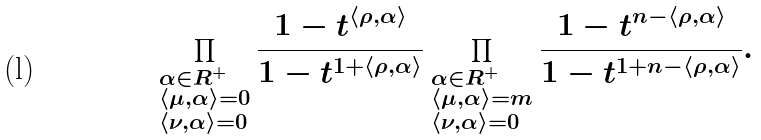Convert formula to latex. <formula><loc_0><loc_0><loc_500><loc_500>\prod _ { \begin{subarray} { c } \alpha \in R ^ { + } \\ \langle \mu , \alpha \rangle = 0 \\ \langle \nu , \alpha \rangle = 0 \end{subarray} } \frac { 1 - t ^ { \langle \rho , \alpha \rangle } } { 1 - t ^ { 1 + \langle \rho , \alpha \rangle } } \prod _ { \begin{subarray} { c } \alpha \in R ^ { + } \\ \langle \mu , \alpha \rangle = m \\ \langle \nu , \alpha \rangle = 0 \end{subarray} } \frac { 1 - t ^ { n - \langle \rho , \alpha \rangle } } { 1 - t ^ { 1 + n - \langle \rho , \alpha \rangle } } .</formula> 